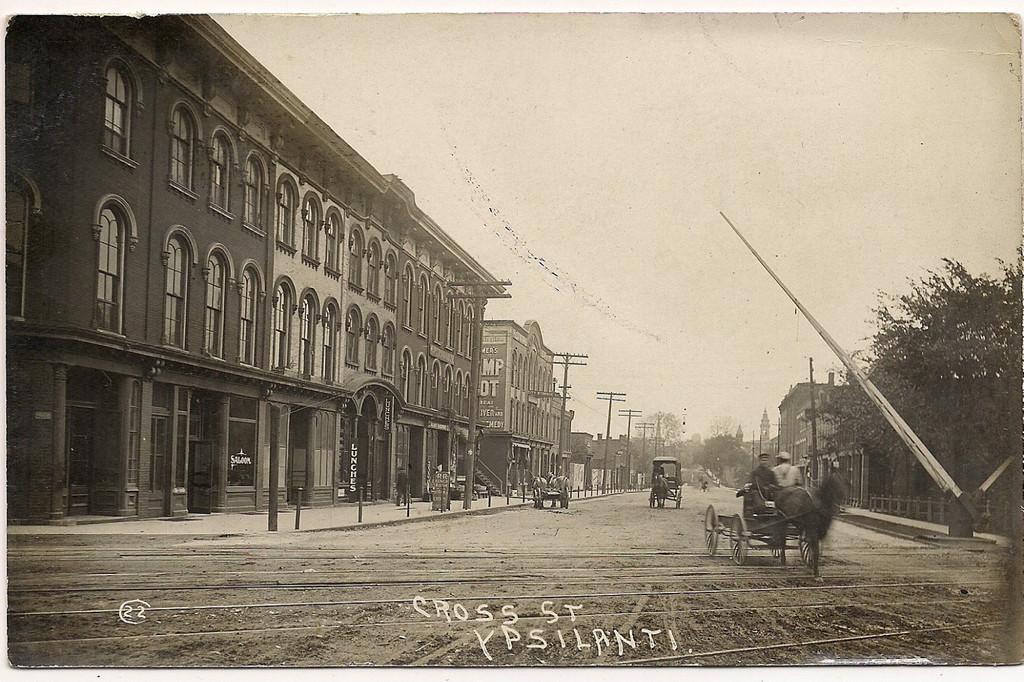Could you give a brief overview of what you see in this image? This is a black and white image. In this image we can see a group of buildings, some people riding horse carts on the ground, some utility poles, a group of trees and the sky which looks cloudy. On the bottom of the image we can see some text. 